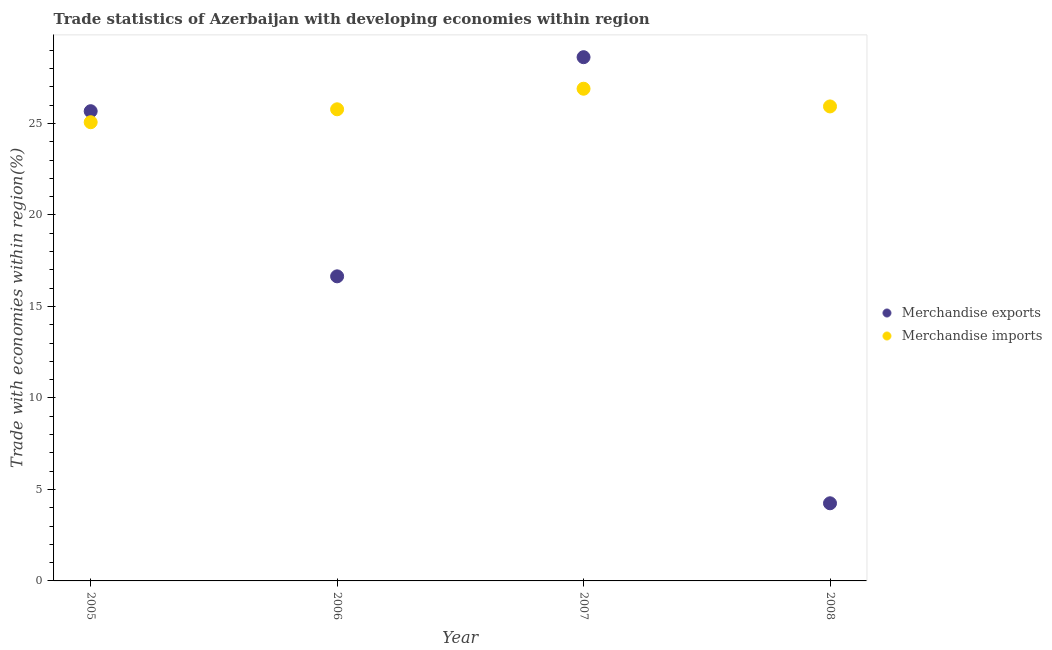Is the number of dotlines equal to the number of legend labels?
Offer a very short reply. Yes. What is the merchandise imports in 2005?
Make the answer very short. 25.07. Across all years, what is the maximum merchandise imports?
Keep it short and to the point. 26.9. Across all years, what is the minimum merchandise imports?
Provide a succinct answer. 25.07. In which year was the merchandise exports maximum?
Offer a terse response. 2007. In which year was the merchandise exports minimum?
Your answer should be compact. 2008. What is the total merchandise exports in the graph?
Your answer should be compact. 75.18. What is the difference between the merchandise exports in 2006 and that in 2008?
Keep it short and to the point. 12.4. What is the difference between the merchandise exports in 2006 and the merchandise imports in 2005?
Your response must be concise. -8.42. What is the average merchandise exports per year?
Keep it short and to the point. 18.8. In the year 2007, what is the difference between the merchandise imports and merchandise exports?
Your answer should be compact. -1.72. In how many years, is the merchandise imports greater than 24 %?
Provide a short and direct response. 4. What is the ratio of the merchandise imports in 2006 to that in 2007?
Offer a terse response. 0.96. Is the merchandise exports in 2006 less than that in 2007?
Your response must be concise. Yes. What is the difference between the highest and the second highest merchandise exports?
Ensure brevity in your answer.  2.95. What is the difference between the highest and the lowest merchandise imports?
Keep it short and to the point. 1.83. In how many years, is the merchandise imports greater than the average merchandise imports taken over all years?
Provide a short and direct response. 2. Is the sum of the merchandise exports in 2005 and 2006 greater than the maximum merchandise imports across all years?
Give a very brief answer. Yes. Does the merchandise imports monotonically increase over the years?
Provide a short and direct response. No. Are the values on the major ticks of Y-axis written in scientific E-notation?
Your answer should be compact. No. Does the graph contain any zero values?
Offer a terse response. No. Does the graph contain grids?
Provide a short and direct response. No. Where does the legend appear in the graph?
Give a very brief answer. Center right. What is the title of the graph?
Make the answer very short. Trade statistics of Azerbaijan with developing economies within region. Does "Diarrhea" appear as one of the legend labels in the graph?
Make the answer very short. No. What is the label or title of the Y-axis?
Keep it short and to the point. Trade with economies within region(%). What is the Trade with economies within region(%) in Merchandise exports in 2005?
Your answer should be very brief. 25.67. What is the Trade with economies within region(%) of Merchandise imports in 2005?
Provide a succinct answer. 25.07. What is the Trade with economies within region(%) in Merchandise exports in 2006?
Provide a succinct answer. 16.65. What is the Trade with economies within region(%) of Merchandise imports in 2006?
Keep it short and to the point. 25.77. What is the Trade with economies within region(%) in Merchandise exports in 2007?
Offer a very short reply. 28.62. What is the Trade with economies within region(%) of Merchandise imports in 2007?
Your answer should be compact. 26.9. What is the Trade with economies within region(%) of Merchandise exports in 2008?
Offer a terse response. 4.24. What is the Trade with economies within region(%) of Merchandise imports in 2008?
Offer a very short reply. 25.93. Across all years, what is the maximum Trade with economies within region(%) of Merchandise exports?
Ensure brevity in your answer.  28.62. Across all years, what is the maximum Trade with economies within region(%) of Merchandise imports?
Your answer should be very brief. 26.9. Across all years, what is the minimum Trade with economies within region(%) in Merchandise exports?
Ensure brevity in your answer.  4.24. Across all years, what is the minimum Trade with economies within region(%) of Merchandise imports?
Offer a very short reply. 25.07. What is the total Trade with economies within region(%) of Merchandise exports in the graph?
Provide a short and direct response. 75.18. What is the total Trade with economies within region(%) in Merchandise imports in the graph?
Keep it short and to the point. 103.67. What is the difference between the Trade with economies within region(%) in Merchandise exports in 2005 and that in 2006?
Your answer should be very brief. 9.02. What is the difference between the Trade with economies within region(%) of Merchandise imports in 2005 and that in 2006?
Offer a terse response. -0.71. What is the difference between the Trade with economies within region(%) of Merchandise exports in 2005 and that in 2007?
Give a very brief answer. -2.95. What is the difference between the Trade with economies within region(%) of Merchandise imports in 2005 and that in 2007?
Provide a short and direct response. -1.83. What is the difference between the Trade with economies within region(%) of Merchandise exports in 2005 and that in 2008?
Give a very brief answer. 21.43. What is the difference between the Trade with economies within region(%) in Merchandise imports in 2005 and that in 2008?
Offer a terse response. -0.86. What is the difference between the Trade with economies within region(%) in Merchandise exports in 2006 and that in 2007?
Provide a succinct answer. -11.98. What is the difference between the Trade with economies within region(%) in Merchandise imports in 2006 and that in 2007?
Keep it short and to the point. -1.12. What is the difference between the Trade with economies within region(%) of Merchandise exports in 2006 and that in 2008?
Provide a short and direct response. 12.4. What is the difference between the Trade with economies within region(%) of Merchandise imports in 2006 and that in 2008?
Provide a succinct answer. -0.16. What is the difference between the Trade with economies within region(%) of Merchandise exports in 2007 and that in 2008?
Provide a short and direct response. 24.38. What is the difference between the Trade with economies within region(%) of Merchandise imports in 2007 and that in 2008?
Provide a succinct answer. 0.97. What is the difference between the Trade with economies within region(%) of Merchandise exports in 2005 and the Trade with economies within region(%) of Merchandise imports in 2006?
Make the answer very short. -0.1. What is the difference between the Trade with economies within region(%) of Merchandise exports in 2005 and the Trade with economies within region(%) of Merchandise imports in 2007?
Ensure brevity in your answer.  -1.23. What is the difference between the Trade with economies within region(%) in Merchandise exports in 2005 and the Trade with economies within region(%) in Merchandise imports in 2008?
Offer a very short reply. -0.26. What is the difference between the Trade with economies within region(%) in Merchandise exports in 2006 and the Trade with economies within region(%) in Merchandise imports in 2007?
Offer a terse response. -10.25. What is the difference between the Trade with economies within region(%) of Merchandise exports in 2006 and the Trade with economies within region(%) of Merchandise imports in 2008?
Keep it short and to the point. -9.29. What is the difference between the Trade with economies within region(%) in Merchandise exports in 2007 and the Trade with economies within region(%) in Merchandise imports in 2008?
Your response must be concise. 2.69. What is the average Trade with economies within region(%) in Merchandise exports per year?
Keep it short and to the point. 18.8. What is the average Trade with economies within region(%) in Merchandise imports per year?
Ensure brevity in your answer.  25.92. In the year 2005, what is the difference between the Trade with economies within region(%) in Merchandise exports and Trade with economies within region(%) in Merchandise imports?
Ensure brevity in your answer.  0.6. In the year 2006, what is the difference between the Trade with economies within region(%) in Merchandise exports and Trade with economies within region(%) in Merchandise imports?
Give a very brief answer. -9.13. In the year 2007, what is the difference between the Trade with economies within region(%) of Merchandise exports and Trade with economies within region(%) of Merchandise imports?
Offer a very short reply. 1.72. In the year 2008, what is the difference between the Trade with economies within region(%) in Merchandise exports and Trade with economies within region(%) in Merchandise imports?
Your answer should be very brief. -21.69. What is the ratio of the Trade with economies within region(%) of Merchandise exports in 2005 to that in 2006?
Offer a terse response. 1.54. What is the ratio of the Trade with economies within region(%) of Merchandise imports in 2005 to that in 2006?
Keep it short and to the point. 0.97. What is the ratio of the Trade with economies within region(%) in Merchandise exports in 2005 to that in 2007?
Your response must be concise. 0.9. What is the ratio of the Trade with economies within region(%) in Merchandise imports in 2005 to that in 2007?
Your answer should be very brief. 0.93. What is the ratio of the Trade with economies within region(%) in Merchandise exports in 2005 to that in 2008?
Offer a very short reply. 6.05. What is the ratio of the Trade with economies within region(%) in Merchandise imports in 2005 to that in 2008?
Offer a terse response. 0.97. What is the ratio of the Trade with economies within region(%) in Merchandise exports in 2006 to that in 2007?
Provide a short and direct response. 0.58. What is the ratio of the Trade with economies within region(%) in Merchandise imports in 2006 to that in 2007?
Keep it short and to the point. 0.96. What is the ratio of the Trade with economies within region(%) of Merchandise exports in 2006 to that in 2008?
Keep it short and to the point. 3.92. What is the ratio of the Trade with economies within region(%) of Merchandise exports in 2007 to that in 2008?
Your response must be concise. 6.75. What is the ratio of the Trade with economies within region(%) of Merchandise imports in 2007 to that in 2008?
Offer a very short reply. 1.04. What is the difference between the highest and the second highest Trade with economies within region(%) in Merchandise exports?
Your response must be concise. 2.95. What is the difference between the highest and the second highest Trade with economies within region(%) in Merchandise imports?
Give a very brief answer. 0.97. What is the difference between the highest and the lowest Trade with economies within region(%) of Merchandise exports?
Ensure brevity in your answer.  24.38. What is the difference between the highest and the lowest Trade with economies within region(%) of Merchandise imports?
Your response must be concise. 1.83. 